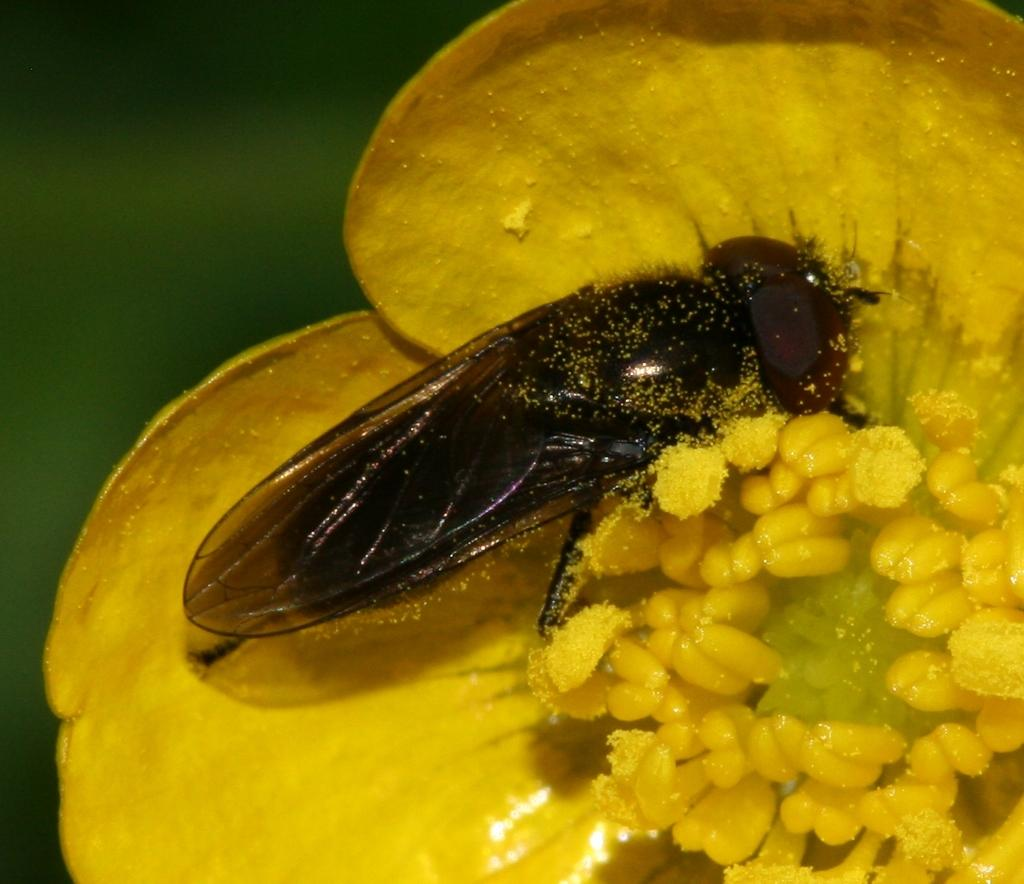What is the main subject of the image? There is an insect in the image. Where is the insect located? The insect is on a yellow flower. Can you describe the background of the image? The background of the image is blurred. What is the insect's monthly income in the image? There is no information about the insect's income in the image. Insects do not have income. 